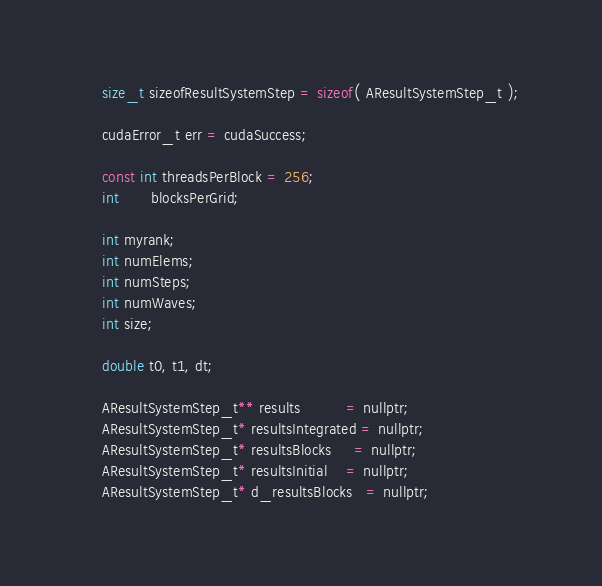<code> <loc_0><loc_0><loc_500><loc_500><_Cuda_>	size_t sizeofResultSystemStep = sizeof( AResultSystemStep_t );

	cudaError_t err = cudaSuccess;

	const int threadsPerBlock = 256;
	int       blocksPerGrid;

	int myrank;
	int numElems;
	int numSteps;
	int numWaves;
	int size;

	double t0, t1, dt;

	AResultSystemStep_t** results          = nullptr;
	AResultSystemStep_t* resultsIntegrated = nullptr;
	AResultSystemStep_t* resultsBlocks     = nullptr;
	AResultSystemStep_t* resultsInitial    = nullptr;
	AResultSystemStep_t* d_resultsBlocks   = nullptr;</code> 